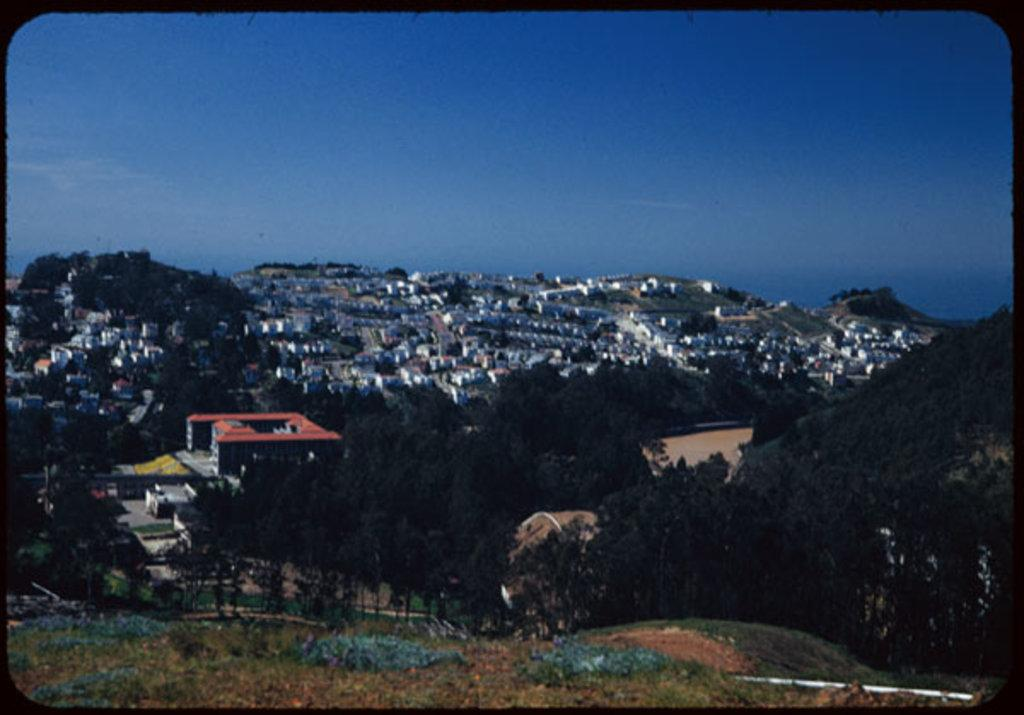What type of vegetation is present in the image? There is grass in the image. What can be seen in the distance behind the grass? There are trees and buildings in the background of the image. What part of the natural environment is visible in the image? The sky is visible in the background of the image. Can you tell me the answer the boy is holding in the image? There is no boy present in the image, so there is no answer to reference. 